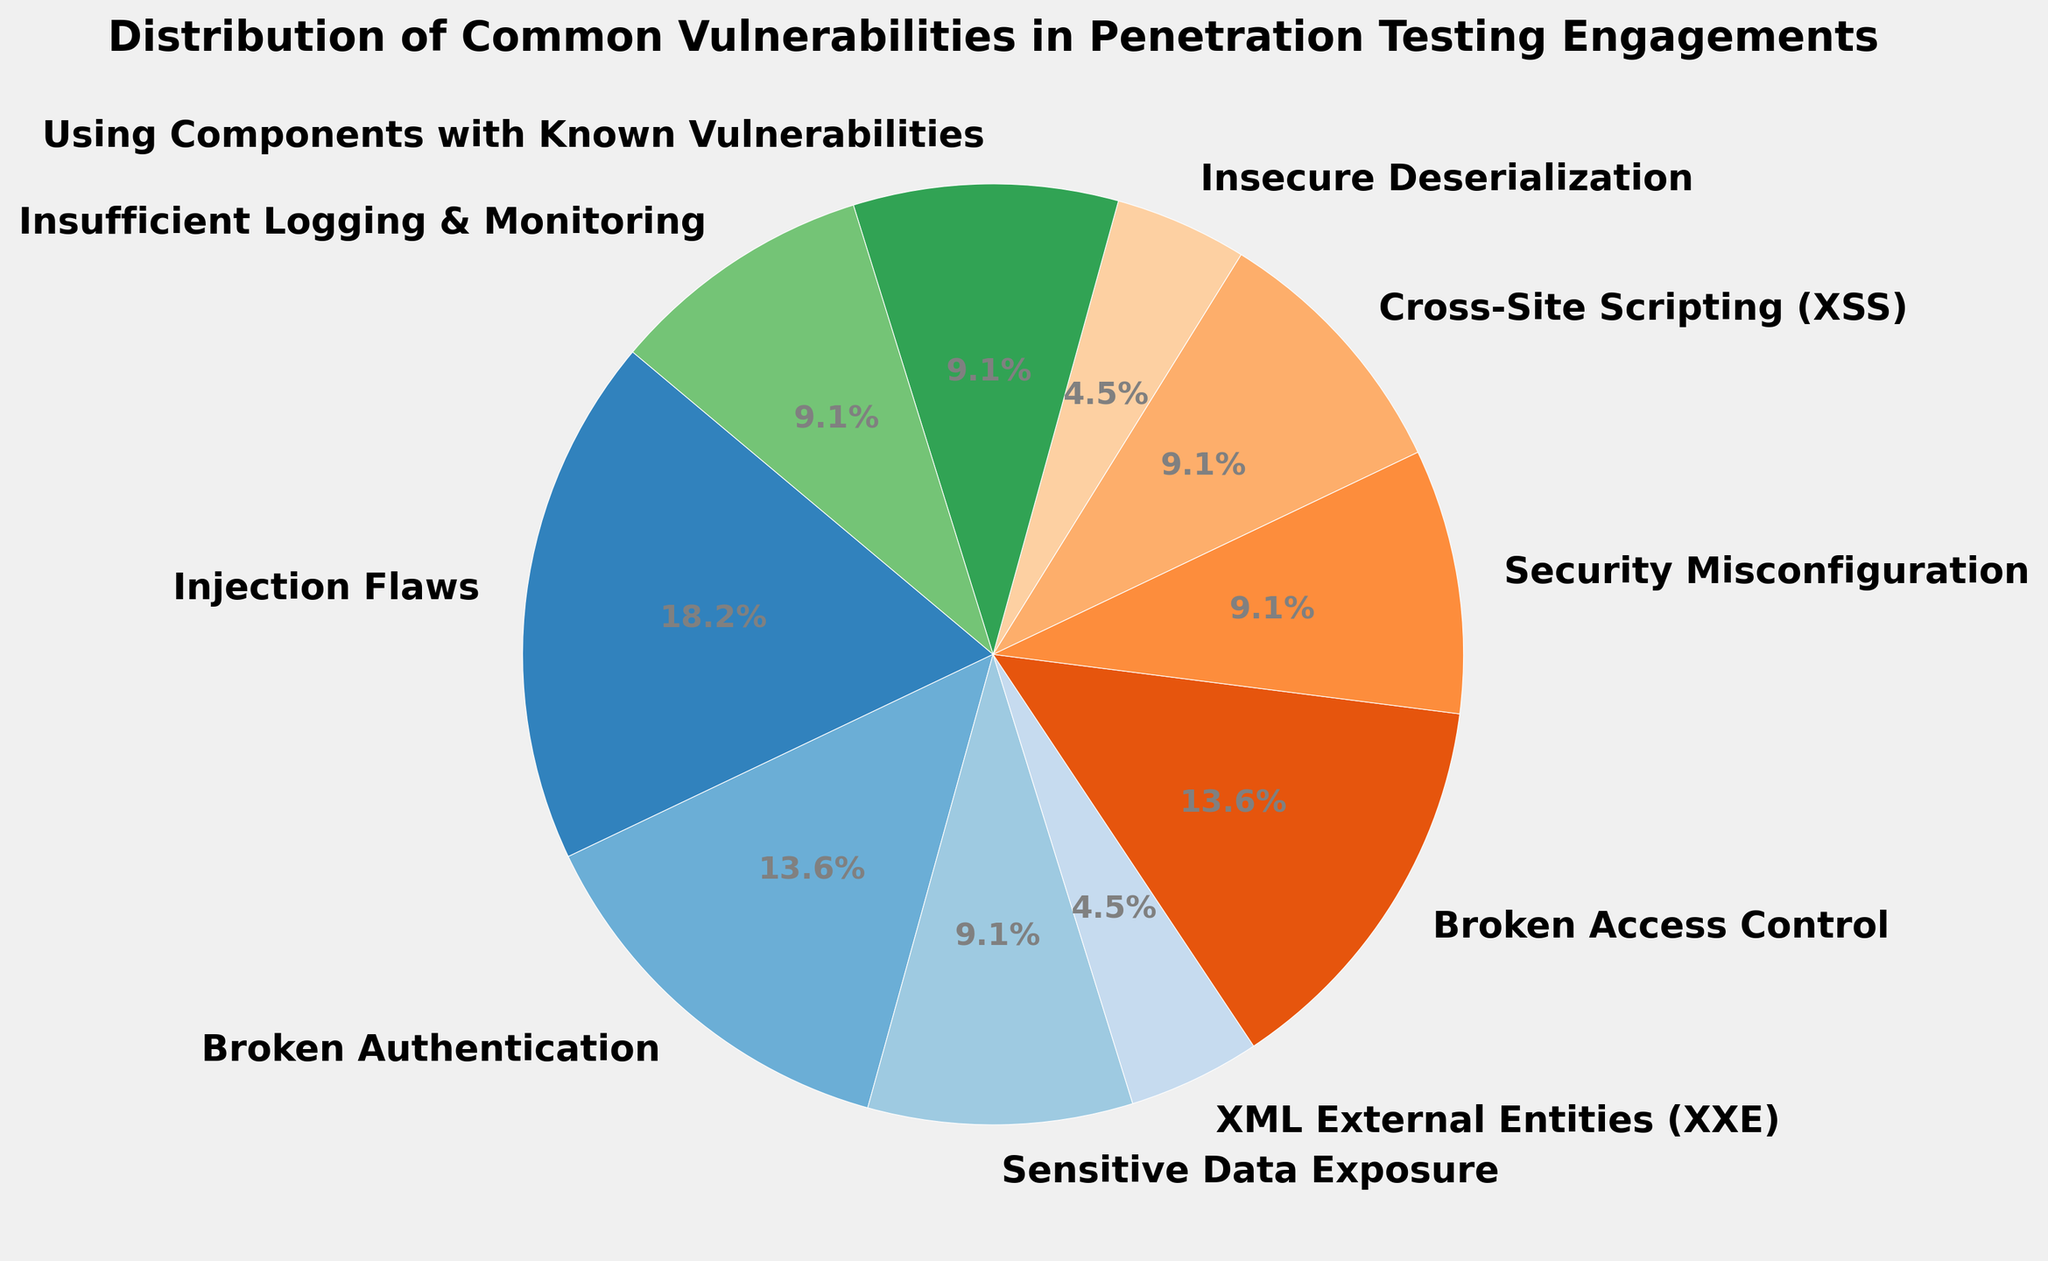Which category has the highest percentage? The category with the highest percentage is displayed with the largest wedge in the pie chart. Identify the largest wedge to determine the category.
Answer: Injection Flaws How many categories have a percentage of 10%? Count the wedges labeled with a percentage value of 10%.
Answer: Four What is the sum of the percentages for Injection Flaws and Broken Authentication? Add the percentages for Injection Flaws (20%) and Broken Authentication (15%).
Answer: 35% Is the percentage of Cross-Site Scripting (XSS) equal to the percentage of Insufficient Logging & Monitoring? Compare the percentages of Cross-Site Scripting (XSS) and Insufficient Logging & Monitoring. Both have labels indicating their percentages.
Answer: Yes Which category has a lower percentage: Security Misconfiguration or Insecure Deserialization? Compare the wedges labeled Security Misconfiguration (10%) and Insecure Deserialization (5%) to see which is lower.
Answer: Insecure Deserialization What is the total percentage of categories that have a percentage less than 10%? Identify the categories with percentages less than 10% (XML External Entities (XXE) and Insecure Deserialization), then sum their percentages (5% + 5%).
Answer: 10% Are there any categories with the same percentage? Check if any two wedges have the same percentage label.
Answer: Yes What is the average percentage of the three largest categories? Identify the three largest categories (Injection Flaws, Broken Authentication, and Broken Access Control), then calculate their average: (20% + 15% + 15%) / 3.
Answer: 16.67% What combined percentage do the three smallest categories represent? Identify the three smallest categories (XML External Entities (XXE), Insecure Deserialization, and any category with 10%), then sum their percentages: 5% + 5% + 10%.
Answer: 20% What is the difference in percentage between the largest and the smallest category? Subtract the percentage of the smallest category (5%, XML External Entities (XXE)) from the largest category (20%, Injection Flaws): 20% - 5%.
Answer: 15% 